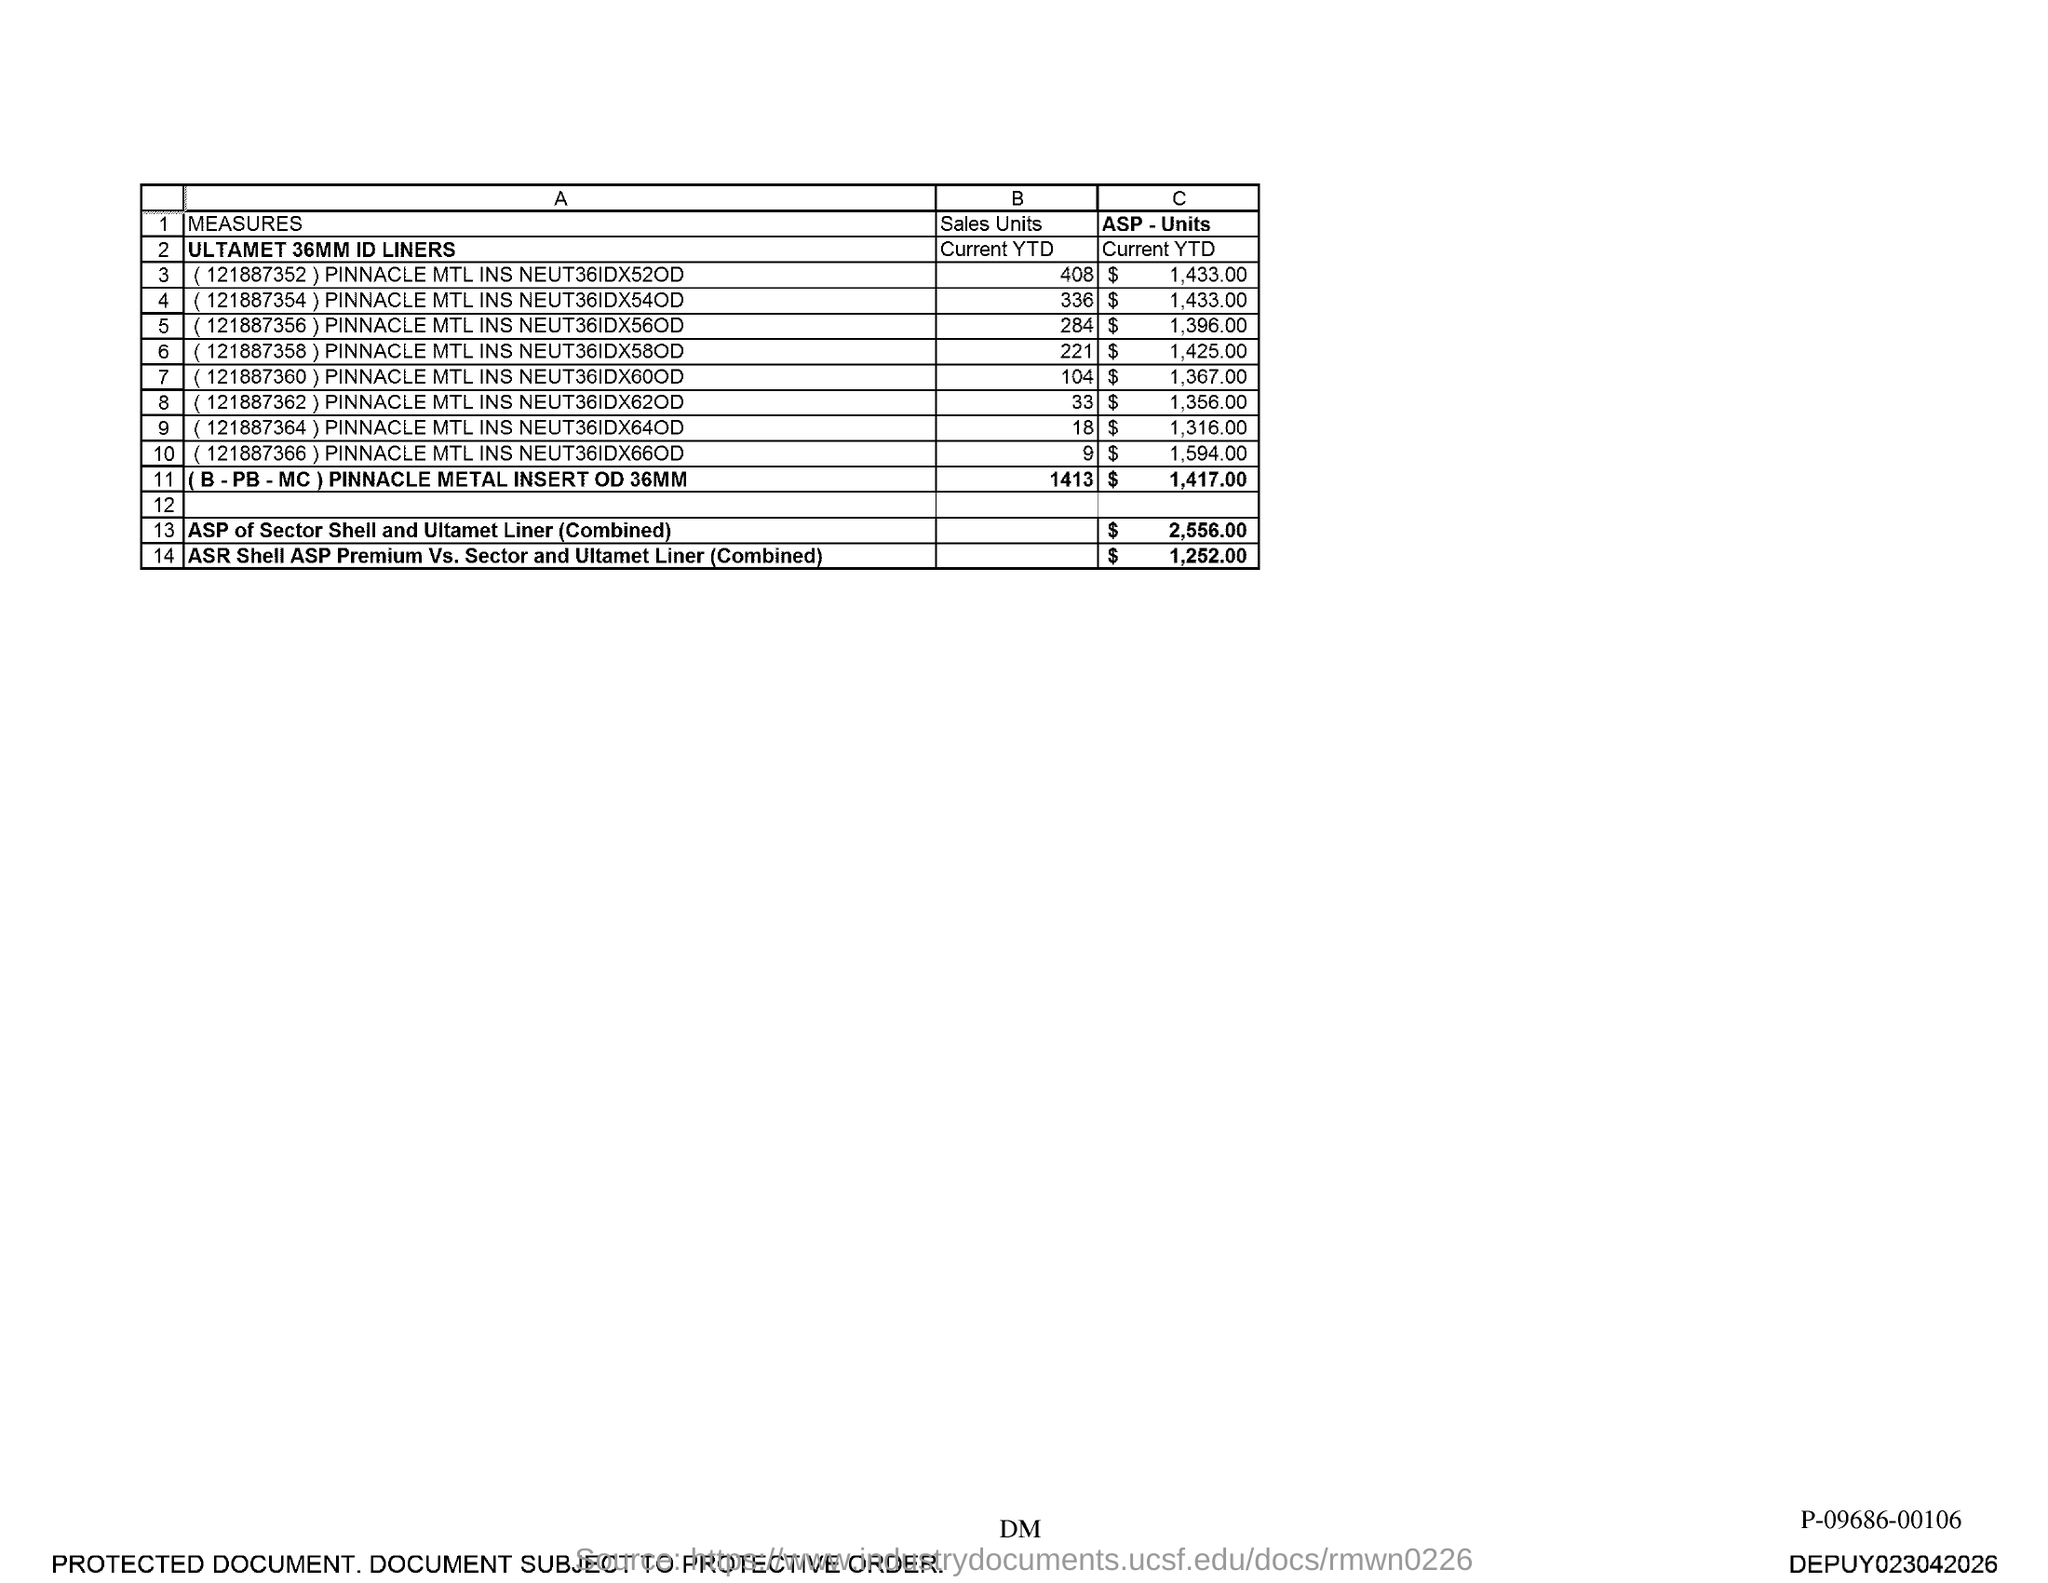Mention a couple of crucial points in this snapshot. The question asks for the sales units for an order with the number (121887352) from Pinnacle MTL with a neut36idx52od. The specific number 408 is mentioned in the context of the sales units. 